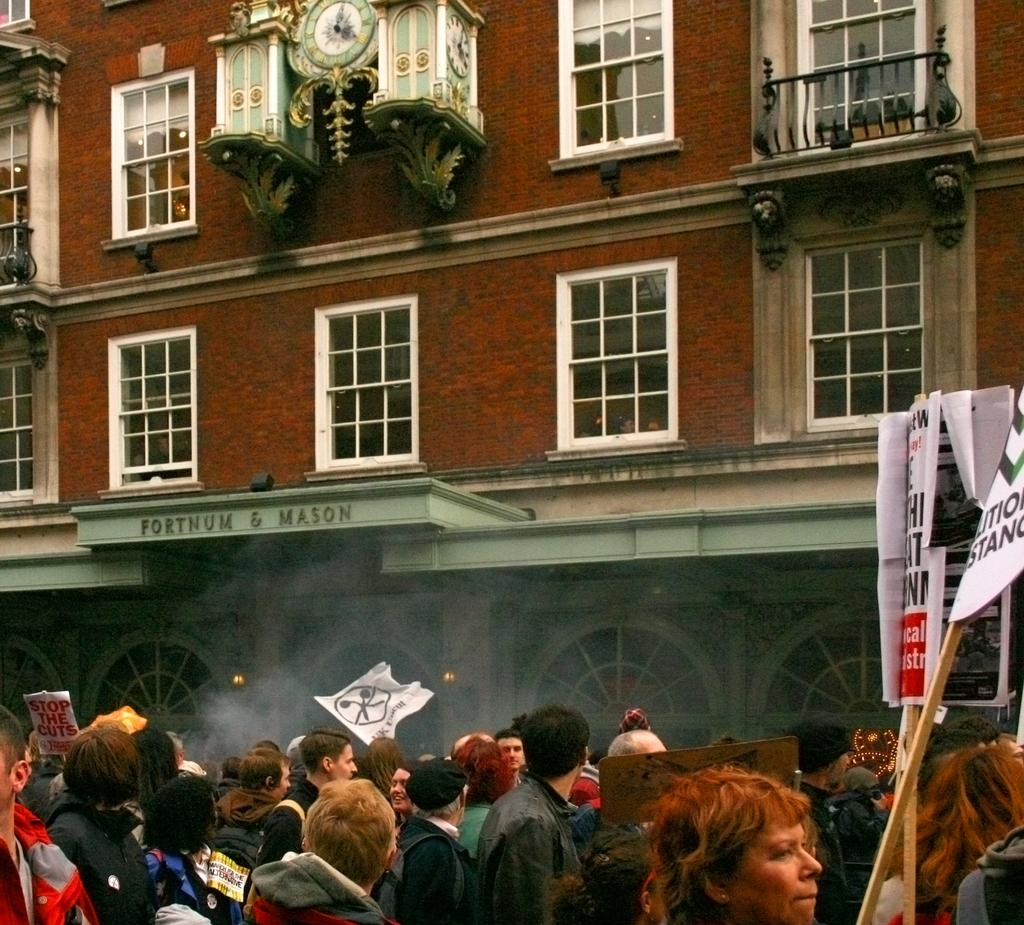Who or what can be seen in the image? There are people in the image. What are the people doing in front of the building? The people are standing in front of a building. What are the people holding in their hands? The people are holding placards. What can be seen on the building in the image? There is an object that looks like a clock on the building. What type of payment is being made in the image? There is no payment being made in the image; it features people standing in front of a building with placards. Can you see a scarecrow in the image? There is no scarecrow present in the image. 